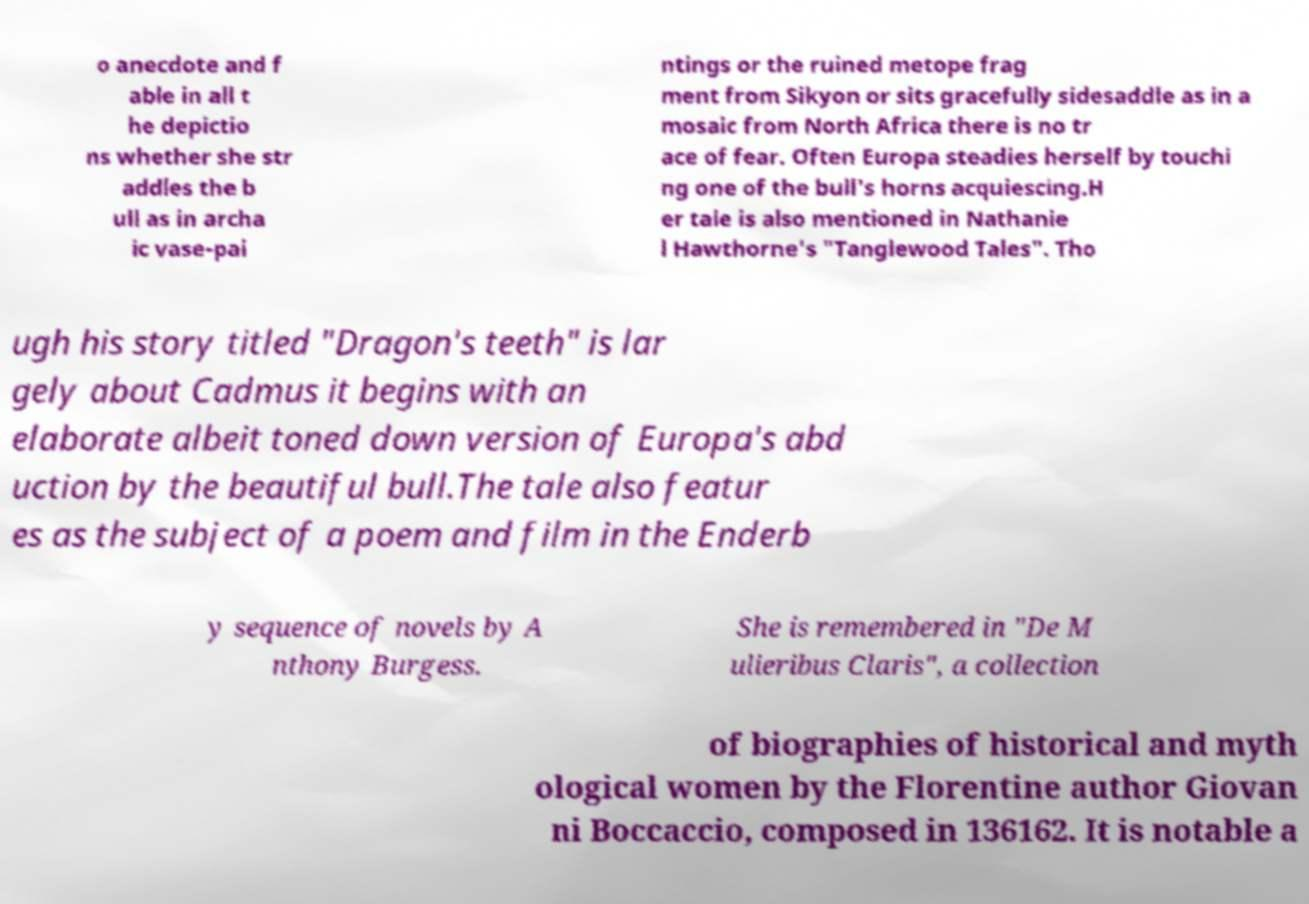Could you assist in decoding the text presented in this image and type it out clearly? o anecdote and f able in all t he depictio ns whether she str addles the b ull as in archa ic vase-pai ntings or the ruined metope frag ment from Sikyon or sits gracefully sidesaddle as in a mosaic from North Africa there is no tr ace of fear. Often Europa steadies herself by touchi ng one of the bull's horns acquiescing.H er tale is also mentioned in Nathanie l Hawthorne's "Tanglewood Tales". Tho ugh his story titled "Dragon's teeth" is lar gely about Cadmus it begins with an elaborate albeit toned down version of Europa's abd uction by the beautiful bull.The tale also featur es as the subject of a poem and film in the Enderb y sequence of novels by A nthony Burgess. She is remembered in "De M ulieribus Claris", a collection of biographies of historical and myth ological women by the Florentine author Giovan ni Boccaccio, composed in 136162. It is notable a 